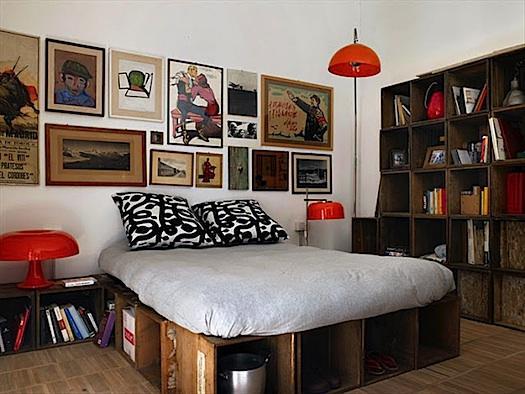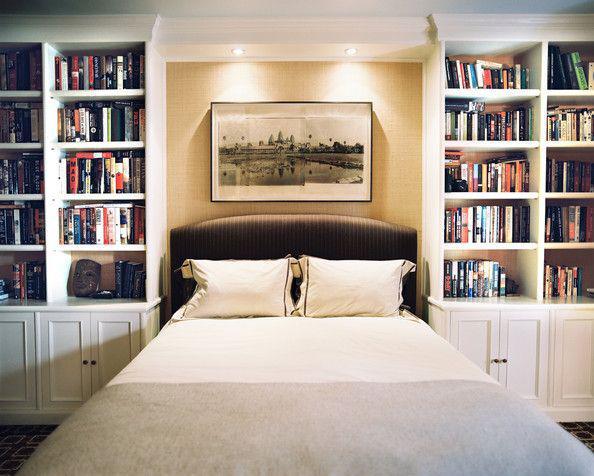The first image is the image on the left, the second image is the image on the right. Given the left and right images, does the statement "An image shows a bed that extends from a recessed area created by bookshelves that surround it." hold true? Answer yes or no. Yes. The first image is the image on the left, the second image is the image on the right. Evaluate the accuracy of this statement regarding the images: "The bookshelf in the image on the right frame an arch.". Is it true? Answer yes or no. No. 